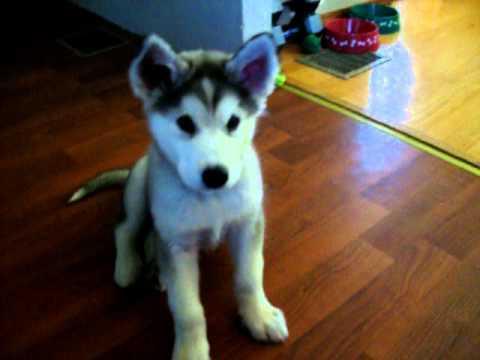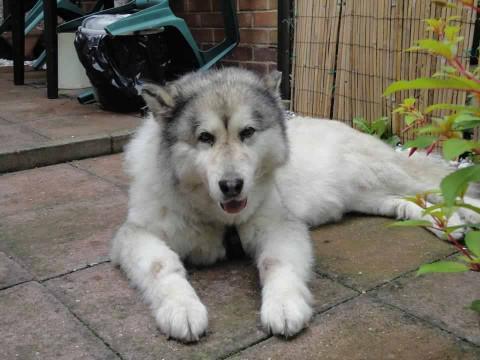The first image is the image on the left, the second image is the image on the right. Analyze the images presented: Is the assertion "Neither of he images in the pair show an adult dog." valid? Answer yes or no. No. The first image is the image on the left, the second image is the image on the right. Assess this claim about the two images: "Each image contains one husky pup with upright ears and muted fur coloring, and one image shows a puppy reclining with front paws extended on a mottled beige floor.". Correct or not? Answer yes or no. No. 